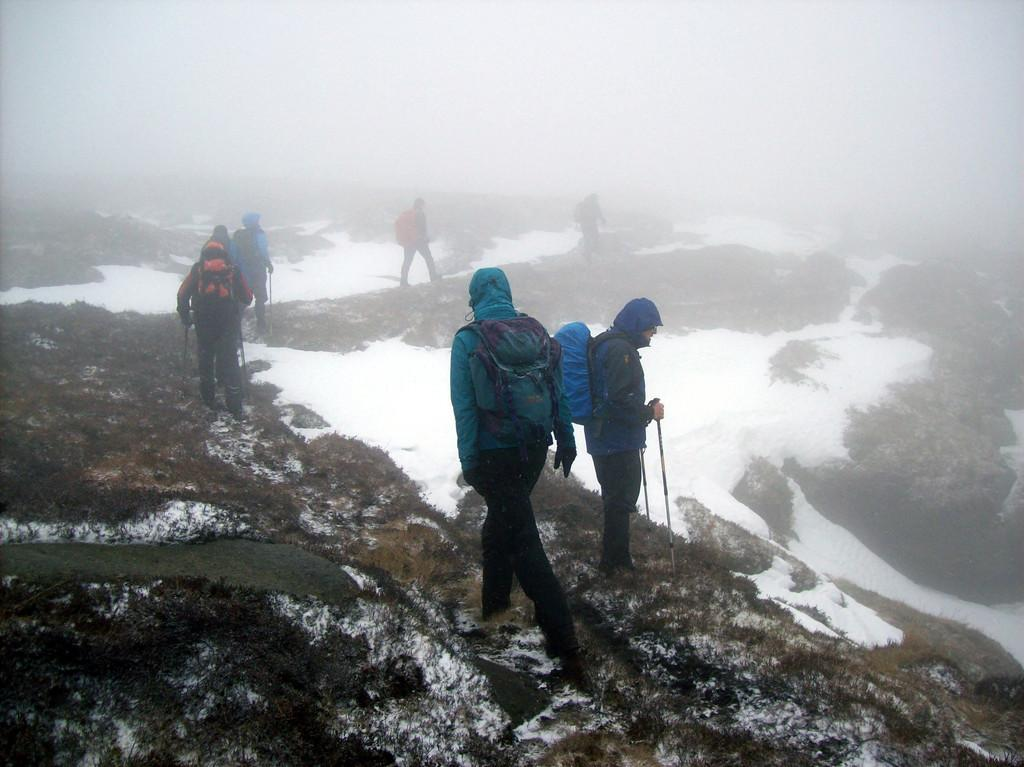What are the people in the image doing? The people in the image are walking. What type of clothing are the people wearing? The people are wearing coats and trousers. What can be seen on the right side of the image? There is snow on the right side of the image. How would you describe the sky in the image? The sky is foggy at the top of the image. What type of shock can be seen on the people's faces in the image? There is no indication of shock on the people's faces in the image; they appear to be walking normally. Can you tell me how many carriages are present in the image? There are no carriages present in the image. 